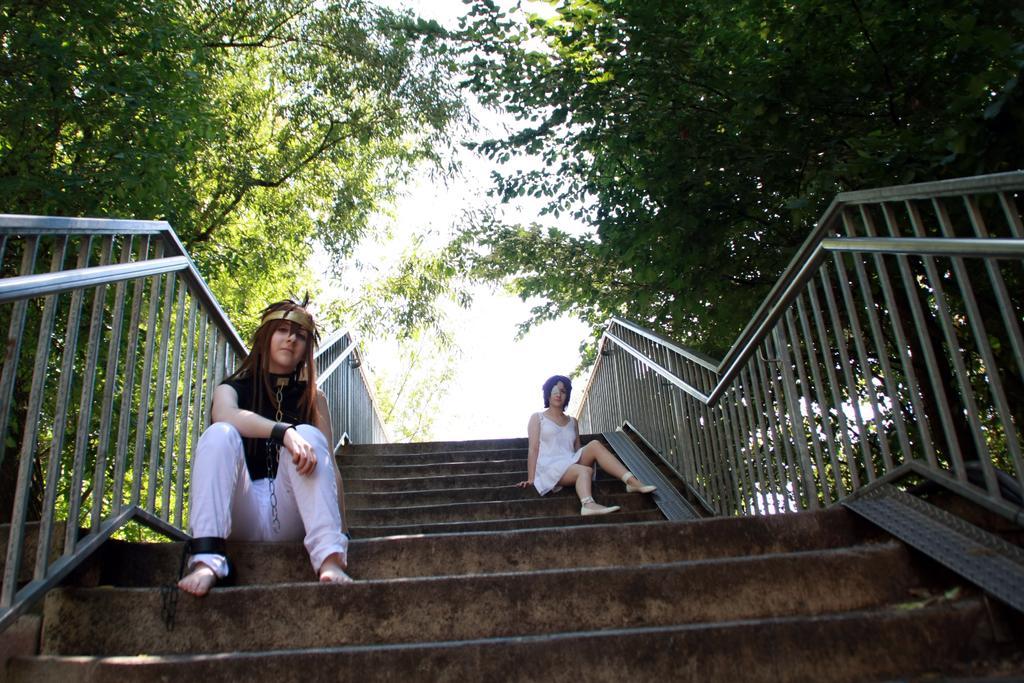Can you describe this image briefly? In this image there are steps. There are two women sitting on the steps. There are chains to the woman who is sitting to the left. On the either sides of the steps there are railings. On the either sides of the image there are trees. At the top there is the sky. 